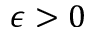<formula> <loc_0><loc_0><loc_500><loc_500>\epsilon > 0</formula> 